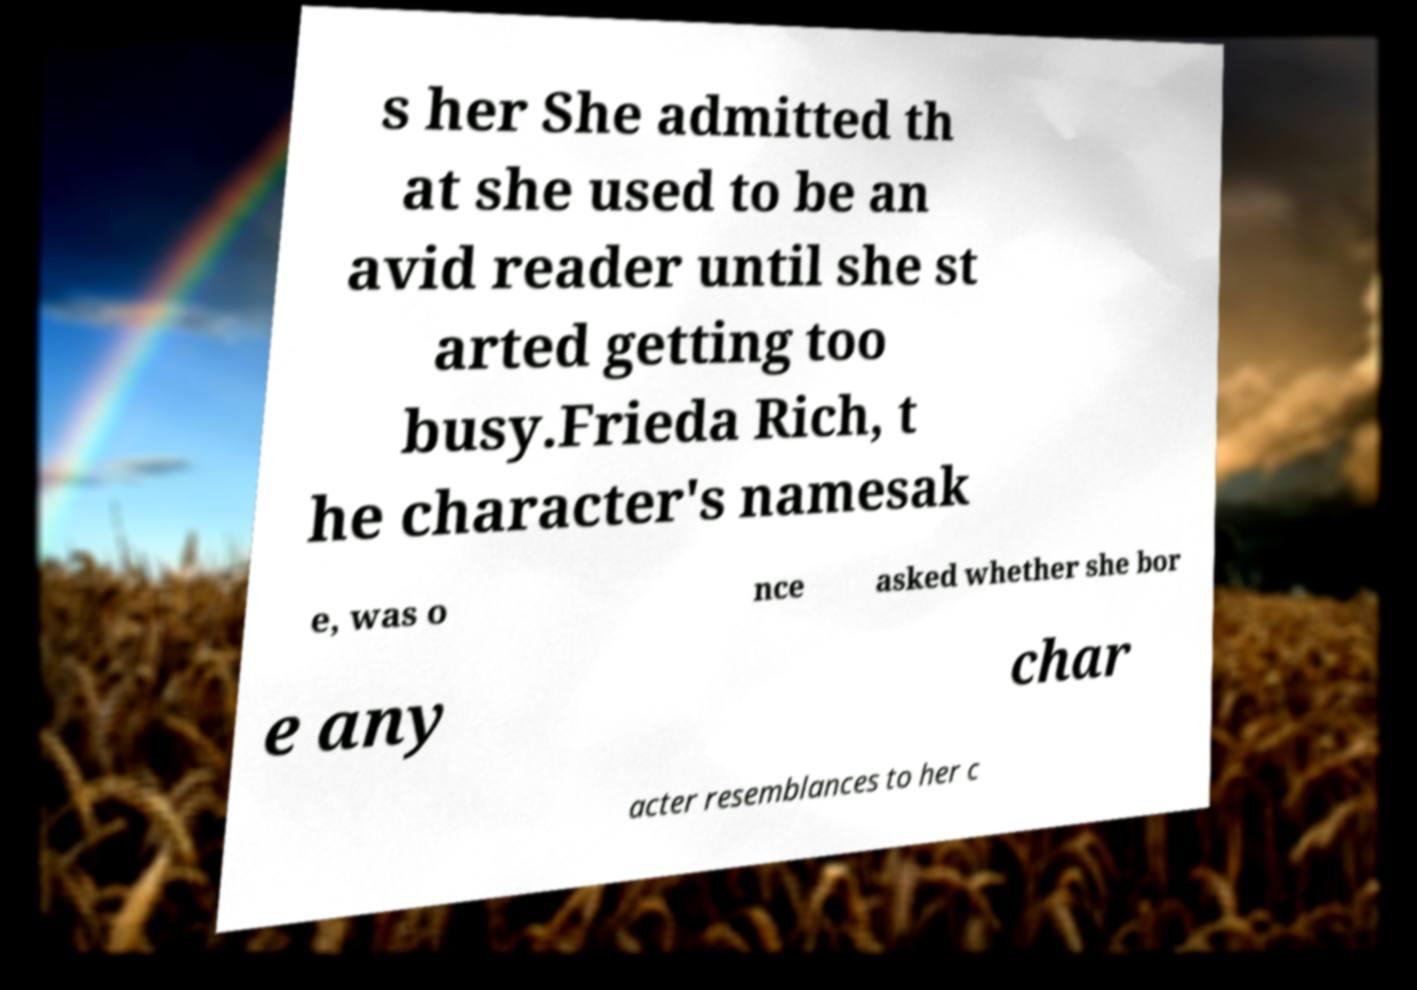Can you read and provide the text displayed in the image?This photo seems to have some interesting text. Can you extract and type it out for me? s her She admitted th at she used to be an avid reader until she st arted getting too busy.Frieda Rich, t he character's namesak e, was o nce asked whether she bor e any char acter resemblances to her c 